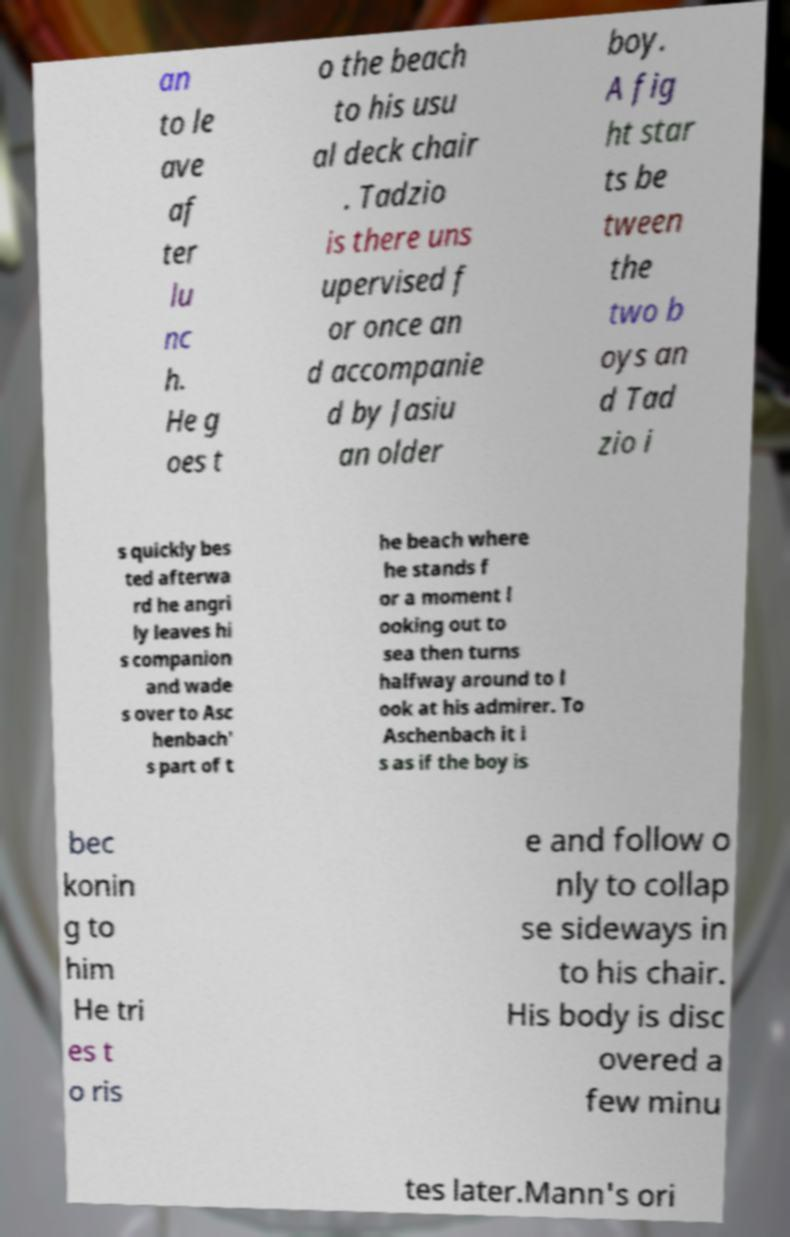There's text embedded in this image that I need extracted. Can you transcribe it verbatim? an to le ave af ter lu nc h. He g oes t o the beach to his usu al deck chair . Tadzio is there uns upervised f or once an d accompanie d by Jasiu an older boy. A fig ht star ts be tween the two b oys an d Tad zio i s quickly bes ted afterwa rd he angri ly leaves hi s companion and wade s over to Asc henbach' s part of t he beach where he stands f or a moment l ooking out to sea then turns halfway around to l ook at his admirer. To Aschenbach it i s as if the boy is bec konin g to him He tri es t o ris e and follow o nly to collap se sideways in to his chair. His body is disc overed a few minu tes later.Mann's ori 